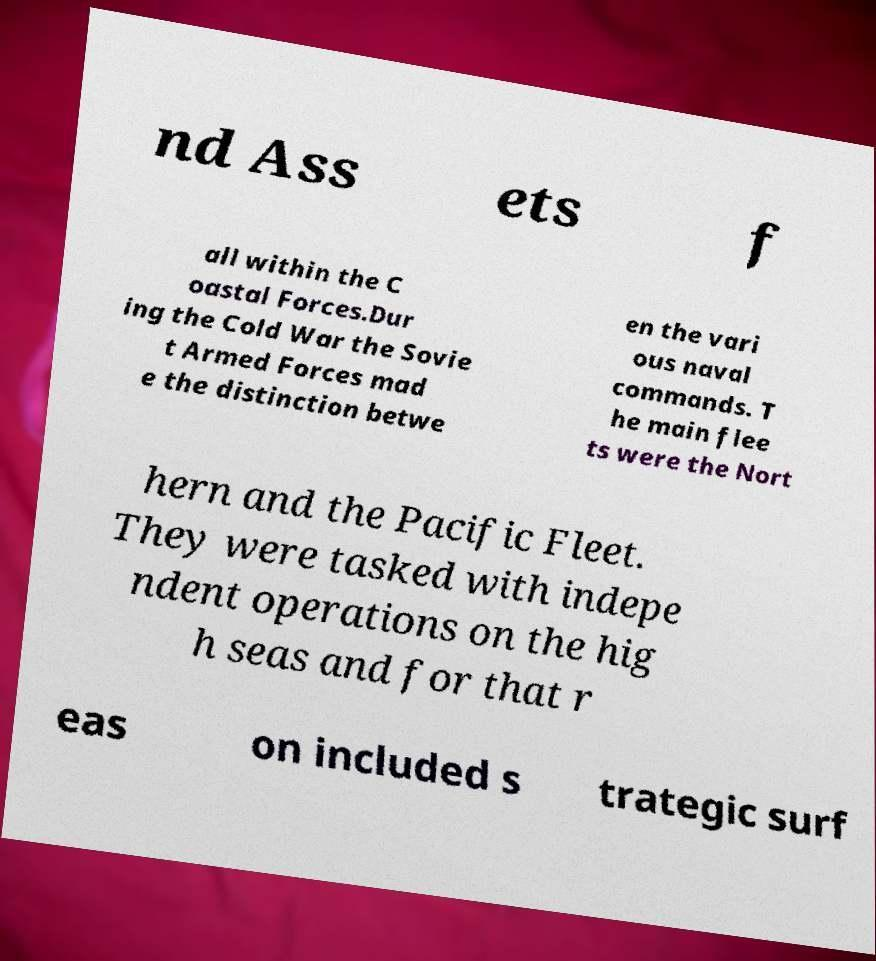Could you assist in decoding the text presented in this image and type it out clearly? nd Ass ets f all within the C oastal Forces.Dur ing the Cold War the Sovie t Armed Forces mad e the distinction betwe en the vari ous naval commands. T he main flee ts were the Nort hern and the Pacific Fleet. They were tasked with indepe ndent operations on the hig h seas and for that r eas on included s trategic surf 